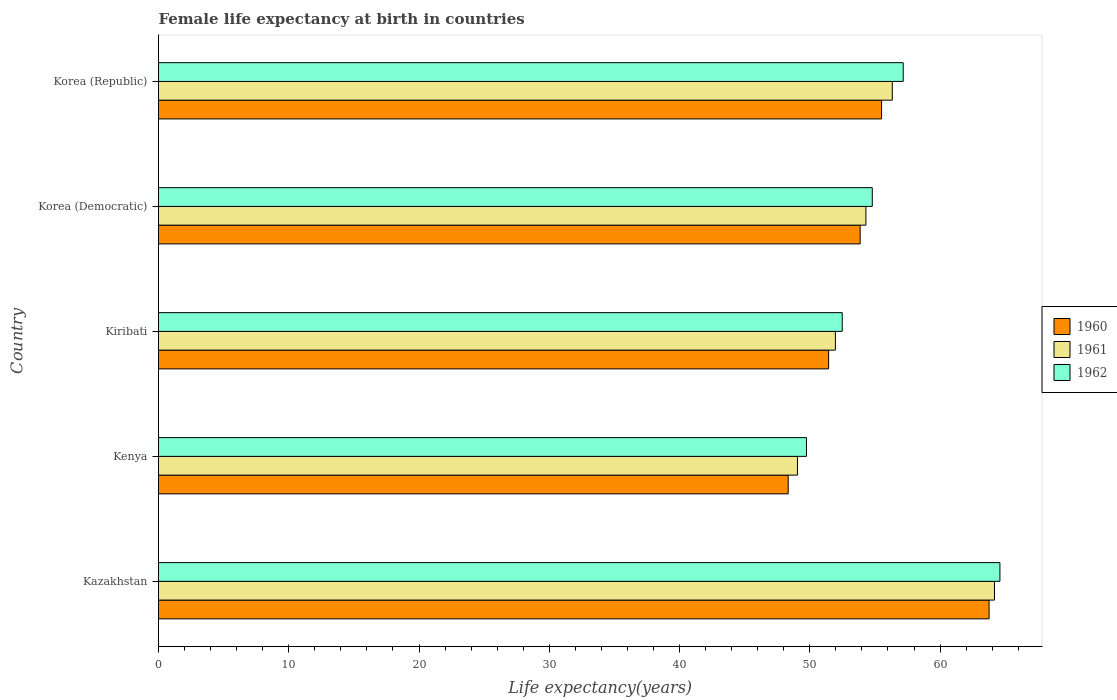How many different coloured bars are there?
Ensure brevity in your answer.  3. Are the number of bars per tick equal to the number of legend labels?
Offer a very short reply. Yes. Are the number of bars on each tick of the Y-axis equal?
Your answer should be compact. Yes. How many bars are there on the 5th tick from the top?
Make the answer very short. 3. What is the label of the 3rd group of bars from the top?
Your response must be concise. Kiribati. In how many cases, is the number of bars for a given country not equal to the number of legend labels?
Your answer should be very brief. 0. What is the female life expectancy at birth in 1961 in Kenya?
Make the answer very short. 49.05. Across all countries, what is the maximum female life expectancy at birth in 1960?
Provide a succinct answer. 63.76. Across all countries, what is the minimum female life expectancy at birth in 1960?
Give a very brief answer. 48.34. In which country was the female life expectancy at birth in 1960 maximum?
Your response must be concise. Kazakhstan. In which country was the female life expectancy at birth in 1960 minimum?
Offer a very short reply. Kenya. What is the total female life expectancy at birth in 1962 in the graph?
Provide a short and direct response. 278.79. What is the difference between the female life expectancy at birth in 1960 in Kiribati and that in Korea (Republic)?
Offer a very short reply. -4.06. What is the difference between the female life expectancy at birth in 1961 in Korea (Democratic) and the female life expectancy at birth in 1960 in Kazakhstan?
Offer a very short reply. -9.46. What is the average female life expectancy at birth in 1960 per country?
Your response must be concise. 54.58. What is the difference between the female life expectancy at birth in 1960 and female life expectancy at birth in 1961 in Korea (Democratic)?
Provide a short and direct response. -0.44. In how many countries, is the female life expectancy at birth in 1960 greater than 56 years?
Provide a short and direct response. 1. What is the ratio of the female life expectancy at birth in 1961 in Kazakhstan to that in Kiribati?
Provide a short and direct response. 1.24. Is the female life expectancy at birth in 1962 in Kazakhstan less than that in Korea (Democratic)?
Make the answer very short. No. What is the difference between the highest and the second highest female life expectancy at birth in 1961?
Provide a succinct answer. 7.84. What is the difference between the highest and the lowest female life expectancy at birth in 1960?
Ensure brevity in your answer.  15.42. Is the sum of the female life expectancy at birth in 1961 in Kazakhstan and Korea (Republic) greater than the maximum female life expectancy at birth in 1962 across all countries?
Your answer should be compact. Yes. What does the 1st bar from the top in Korea (Republic) represents?
Make the answer very short. 1962. Are all the bars in the graph horizontal?
Provide a short and direct response. Yes. Are the values on the major ticks of X-axis written in scientific E-notation?
Your response must be concise. No. Does the graph contain any zero values?
Provide a succinct answer. No. Where does the legend appear in the graph?
Give a very brief answer. Center right. How many legend labels are there?
Provide a short and direct response. 3. How are the legend labels stacked?
Your answer should be very brief. Vertical. What is the title of the graph?
Offer a very short reply. Female life expectancy at birth in countries. Does "2008" appear as one of the legend labels in the graph?
Your answer should be very brief. No. What is the label or title of the X-axis?
Provide a succinct answer. Life expectancy(years). What is the label or title of the Y-axis?
Your answer should be compact. Country. What is the Life expectancy(years) in 1960 in Kazakhstan?
Give a very brief answer. 63.76. What is the Life expectancy(years) in 1961 in Kazakhstan?
Provide a short and direct response. 64.17. What is the Life expectancy(years) of 1962 in Kazakhstan?
Your answer should be compact. 64.59. What is the Life expectancy(years) in 1960 in Kenya?
Provide a succinct answer. 48.34. What is the Life expectancy(years) in 1961 in Kenya?
Provide a succinct answer. 49.05. What is the Life expectancy(years) of 1962 in Kenya?
Your answer should be very brief. 49.74. What is the Life expectancy(years) of 1960 in Kiribati?
Provide a short and direct response. 51.44. What is the Life expectancy(years) in 1961 in Kiribati?
Offer a terse response. 51.96. What is the Life expectancy(years) in 1962 in Kiribati?
Offer a very short reply. 52.49. What is the Life expectancy(years) of 1960 in Korea (Democratic)?
Provide a short and direct response. 53.86. What is the Life expectancy(years) in 1961 in Korea (Democratic)?
Provide a short and direct response. 54.3. What is the Life expectancy(years) of 1962 in Korea (Democratic)?
Your answer should be very brief. 54.79. What is the Life expectancy(years) in 1960 in Korea (Republic)?
Make the answer very short. 55.51. What is the Life expectancy(years) in 1961 in Korea (Republic)?
Your answer should be compact. 56.33. What is the Life expectancy(years) in 1962 in Korea (Republic)?
Your answer should be very brief. 57.17. Across all countries, what is the maximum Life expectancy(years) of 1960?
Your response must be concise. 63.76. Across all countries, what is the maximum Life expectancy(years) of 1961?
Your answer should be very brief. 64.17. Across all countries, what is the maximum Life expectancy(years) of 1962?
Offer a terse response. 64.59. Across all countries, what is the minimum Life expectancy(years) of 1960?
Offer a terse response. 48.34. Across all countries, what is the minimum Life expectancy(years) in 1961?
Provide a short and direct response. 49.05. Across all countries, what is the minimum Life expectancy(years) of 1962?
Offer a terse response. 49.74. What is the total Life expectancy(years) in 1960 in the graph?
Offer a terse response. 272.92. What is the total Life expectancy(years) of 1961 in the graph?
Provide a short and direct response. 275.82. What is the total Life expectancy(years) in 1962 in the graph?
Provide a succinct answer. 278.79. What is the difference between the Life expectancy(years) of 1960 in Kazakhstan and that in Kenya?
Offer a very short reply. 15.42. What is the difference between the Life expectancy(years) of 1961 in Kazakhstan and that in Kenya?
Give a very brief answer. 15.12. What is the difference between the Life expectancy(years) of 1962 in Kazakhstan and that in Kenya?
Ensure brevity in your answer.  14.85. What is the difference between the Life expectancy(years) of 1960 in Kazakhstan and that in Kiribati?
Provide a succinct answer. 12.32. What is the difference between the Life expectancy(years) of 1961 in Kazakhstan and that in Kiribati?
Your answer should be very brief. 12.21. What is the difference between the Life expectancy(years) of 1962 in Kazakhstan and that in Kiribati?
Your response must be concise. 12.11. What is the difference between the Life expectancy(years) of 1960 in Kazakhstan and that in Korea (Democratic)?
Offer a very short reply. 9.9. What is the difference between the Life expectancy(years) in 1961 in Kazakhstan and that in Korea (Democratic)?
Provide a succinct answer. 9.87. What is the difference between the Life expectancy(years) of 1962 in Kazakhstan and that in Korea (Democratic)?
Offer a terse response. 9.8. What is the difference between the Life expectancy(years) of 1960 in Kazakhstan and that in Korea (Republic)?
Your response must be concise. 8.25. What is the difference between the Life expectancy(years) of 1961 in Kazakhstan and that in Korea (Republic)?
Your response must be concise. 7.84. What is the difference between the Life expectancy(years) in 1962 in Kazakhstan and that in Korea (Republic)?
Your response must be concise. 7.42. What is the difference between the Life expectancy(years) in 1960 in Kenya and that in Kiribati?
Offer a very short reply. -3.1. What is the difference between the Life expectancy(years) of 1961 in Kenya and that in Kiribati?
Offer a very short reply. -2.91. What is the difference between the Life expectancy(years) of 1962 in Kenya and that in Kiribati?
Provide a short and direct response. -2.75. What is the difference between the Life expectancy(years) in 1960 in Kenya and that in Korea (Democratic)?
Ensure brevity in your answer.  -5.52. What is the difference between the Life expectancy(years) of 1961 in Kenya and that in Korea (Democratic)?
Provide a succinct answer. -5.25. What is the difference between the Life expectancy(years) of 1962 in Kenya and that in Korea (Democratic)?
Ensure brevity in your answer.  -5.05. What is the difference between the Life expectancy(years) of 1960 in Kenya and that in Korea (Republic)?
Provide a short and direct response. -7.17. What is the difference between the Life expectancy(years) of 1961 in Kenya and that in Korea (Republic)?
Your answer should be compact. -7.28. What is the difference between the Life expectancy(years) of 1962 in Kenya and that in Korea (Republic)?
Give a very brief answer. -7.43. What is the difference between the Life expectancy(years) of 1960 in Kiribati and that in Korea (Democratic)?
Your response must be concise. -2.42. What is the difference between the Life expectancy(years) of 1961 in Kiribati and that in Korea (Democratic)?
Offer a terse response. -2.34. What is the difference between the Life expectancy(years) of 1962 in Kiribati and that in Korea (Democratic)?
Make the answer very short. -2.31. What is the difference between the Life expectancy(years) in 1960 in Kiribati and that in Korea (Republic)?
Your answer should be very brief. -4.07. What is the difference between the Life expectancy(years) in 1961 in Kiribati and that in Korea (Republic)?
Offer a terse response. -4.37. What is the difference between the Life expectancy(years) of 1962 in Kiribati and that in Korea (Republic)?
Offer a very short reply. -4.68. What is the difference between the Life expectancy(years) in 1960 in Korea (Democratic) and that in Korea (Republic)?
Keep it short and to the point. -1.65. What is the difference between the Life expectancy(years) in 1961 in Korea (Democratic) and that in Korea (Republic)?
Offer a very short reply. -2.02. What is the difference between the Life expectancy(years) in 1962 in Korea (Democratic) and that in Korea (Republic)?
Your answer should be very brief. -2.37. What is the difference between the Life expectancy(years) of 1960 in Kazakhstan and the Life expectancy(years) of 1961 in Kenya?
Give a very brief answer. 14.71. What is the difference between the Life expectancy(years) in 1960 in Kazakhstan and the Life expectancy(years) in 1962 in Kenya?
Provide a short and direct response. 14.02. What is the difference between the Life expectancy(years) in 1961 in Kazakhstan and the Life expectancy(years) in 1962 in Kenya?
Provide a short and direct response. 14.43. What is the difference between the Life expectancy(years) in 1960 in Kazakhstan and the Life expectancy(years) in 1961 in Kiribati?
Your response must be concise. 11.8. What is the difference between the Life expectancy(years) in 1960 in Kazakhstan and the Life expectancy(years) in 1962 in Kiribati?
Give a very brief answer. 11.27. What is the difference between the Life expectancy(years) in 1961 in Kazakhstan and the Life expectancy(years) in 1962 in Kiribati?
Provide a succinct answer. 11.69. What is the difference between the Life expectancy(years) in 1960 in Kazakhstan and the Life expectancy(years) in 1961 in Korea (Democratic)?
Your response must be concise. 9.46. What is the difference between the Life expectancy(years) in 1960 in Kazakhstan and the Life expectancy(years) in 1962 in Korea (Democratic)?
Provide a succinct answer. 8.97. What is the difference between the Life expectancy(years) in 1961 in Kazakhstan and the Life expectancy(years) in 1962 in Korea (Democratic)?
Your response must be concise. 9.38. What is the difference between the Life expectancy(years) in 1960 in Kazakhstan and the Life expectancy(years) in 1961 in Korea (Republic)?
Your answer should be compact. 7.43. What is the difference between the Life expectancy(years) of 1960 in Kazakhstan and the Life expectancy(years) of 1962 in Korea (Republic)?
Give a very brief answer. 6.59. What is the difference between the Life expectancy(years) of 1961 in Kazakhstan and the Life expectancy(years) of 1962 in Korea (Republic)?
Your response must be concise. 7.01. What is the difference between the Life expectancy(years) of 1960 in Kenya and the Life expectancy(years) of 1961 in Kiribati?
Give a very brief answer. -3.62. What is the difference between the Life expectancy(years) of 1960 in Kenya and the Life expectancy(years) of 1962 in Kiribati?
Offer a terse response. -4.15. What is the difference between the Life expectancy(years) of 1961 in Kenya and the Life expectancy(years) of 1962 in Kiribati?
Offer a very short reply. -3.44. What is the difference between the Life expectancy(years) in 1960 in Kenya and the Life expectancy(years) in 1961 in Korea (Democratic)?
Provide a succinct answer. -5.96. What is the difference between the Life expectancy(years) in 1960 in Kenya and the Life expectancy(years) in 1962 in Korea (Democratic)?
Provide a succinct answer. -6.45. What is the difference between the Life expectancy(years) in 1961 in Kenya and the Life expectancy(years) in 1962 in Korea (Democratic)?
Your response must be concise. -5.74. What is the difference between the Life expectancy(years) in 1960 in Kenya and the Life expectancy(years) in 1961 in Korea (Republic)?
Your response must be concise. -7.99. What is the difference between the Life expectancy(years) of 1960 in Kenya and the Life expectancy(years) of 1962 in Korea (Republic)?
Offer a very short reply. -8.83. What is the difference between the Life expectancy(years) in 1961 in Kenya and the Life expectancy(years) in 1962 in Korea (Republic)?
Offer a very short reply. -8.12. What is the difference between the Life expectancy(years) in 1960 in Kiribati and the Life expectancy(years) in 1961 in Korea (Democratic)?
Offer a terse response. -2.86. What is the difference between the Life expectancy(years) in 1960 in Kiribati and the Life expectancy(years) in 1962 in Korea (Democratic)?
Ensure brevity in your answer.  -3.35. What is the difference between the Life expectancy(years) of 1961 in Kiribati and the Life expectancy(years) of 1962 in Korea (Democratic)?
Provide a succinct answer. -2.83. What is the difference between the Life expectancy(years) in 1960 in Kiribati and the Life expectancy(years) in 1961 in Korea (Republic)?
Provide a short and direct response. -4.89. What is the difference between the Life expectancy(years) in 1960 in Kiribati and the Life expectancy(years) in 1962 in Korea (Republic)?
Offer a very short reply. -5.72. What is the difference between the Life expectancy(years) in 1961 in Kiribati and the Life expectancy(years) in 1962 in Korea (Republic)?
Provide a short and direct response. -5.21. What is the difference between the Life expectancy(years) of 1960 in Korea (Democratic) and the Life expectancy(years) of 1961 in Korea (Republic)?
Your response must be concise. -2.47. What is the difference between the Life expectancy(years) of 1960 in Korea (Democratic) and the Life expectancy(years) of 1962 in Korea (Republic)?
Your response must be concise. -3.31. What is the difference between the Life expectancy(years) in 1961 in Korea (Democratic) and the Life expectancy(years) in 1962 in Korea (Republic)?
Your answer should be very brief. -2.86. What is the average Life expectancy(years) of 1960 per country?
Your answer should be compact. 54.58. What is the average Life expectancy(years) of 1961 per country?
Your response must be concise. 55.16. What is the average Life expectancy(years) of 1962 per country?
Keep it short and to the point. 55.76. What is the difference between the Life expectancy(years) in 1960 and Life expectancy(years) in 1961 in Kazakhstan?
Provide a short and direct response. -0.41. What is the difference between the Life expectancy(years) in 1960 and Life expectancy(years) in 1962 in Kazakhstan?
Offer a very short reply. -0.83. What is the difference between the Life expectancy(years) in 1961 and Life expectancy(years) in 1962 in Kazakhstan?
Your response must be concise. -0.42. What is the difference between the Life expectancy(years) in 1960 and Life expectancy(years) in 1961 in Kenya?
Make the answer very short. -0.71. What is the difference between the Life expectancy(years) in 1960 and Life expectancy(years) in 1962 in Kenya?
Ensure brevity in your answer.  -1.4. What is the difference between the Life expectancy(years) in 1961 and Life expectancy(years) in 1962 in Kenya?
Offer a very short reply. -0.69. What is the difference between the Life expectancy(years) of 1960 and Life expectancy(years) of 1961 in Kiribati?
Provide a succinct answer. -0.52. What is the difference between the Life expectancy(years) of 1960 and Life expectancy(years) of 1962 in Kiribati?
Your response must be concise. -1.04. What is the difference between the Life expectancy(years) in 1961 and Life expectancy(years) in 1962 in Kiribati?
Make the answer very short. -0.53. What is the difference between the Life expectancy(years) of 1960 and Life expectancy(years) of 1961 in Korea (Democratic)?
Keep it short and to the point. -0.44. What is the difference between the Life expectancy(years) in 1960 and Life expectancy(years) in 1962 in Korea (Democratic)?
Your answer should be very brief. -0.93. What is the difference between the Life expectancy(years) in 1961 and Life expectancy(years) in 1962 in Korea (Democratic)?
Offer a very short reply. -0.49. What is the difference between the Life expectancy(years) of 1960 and Life expectancy(years) of 1961 in Korea (Republic)?
Give a very brief answer. -0.82. What is the difference between the Life expectancy(years) of 1960 and Life expectancy(years) of 1962 in Korea (Republic)?
Keep it short and to the point. -1.66. What is the difference between the Life expectancy(years) of 1961 and Life expectancy(years) of 1962 in Korea (Republic)?
Your answer should be very brief. -0.84. What is the ratio of the Life expectancy(years) of 1960 in Kazakhstan to that in Kenya?
Your answer should be very brief. 1.32. What is the ratio of the Life expectancy(years) of 1961 in Kazakhstan to that in Kenya?
Make the answer very short. 1.31. What is the ratio of the Life expectancy(years) in 1962 in Kazakhstan to that in Kenya?
Offer a very short reply. 1.3. What is the ratio of the Life expectancy(years) of 1960 in Kazakhstan to that in Kiribati?
Provide a succinct answer. 1.24. What is the ratio of the Life expectancy(years) of 1961 in Kazakhstan to that in Kiribati?
Keep it short and to the point. 1.24. What is the ratio of the Life expectancy(years) in 1962 in Kazakhstan to that in Kiribati?
Your answer should be compact. 1.23. What is the ratio of the Life expectancy(years) in 1960 in Kazakhstan to that in Korea (Democratic)?
Your response must be concise. 1.18. What is the ratio of the Life expectancy(years) in 1961 in Kazakhstan to that in Korea (Democratic)?
Ensure brevity in your answer.  1.18. What is the ratio of the Life expectancy(years) in 1962 in Kazakhstan to that in Korea (Democratic)?
Provide a short and direct response. 1.18. What is the ratio of the Life expectancy(years) in 1960 in Kazakhstan to that in Korea (Republic)?
Keep it short and to the point. 1.15. What is the ratio of the Life expectancy(years) of 1961 in Kazakhstan to that in Korea (Republic)?
Offer a very short reply. 1.14. What is the ratio of the Life expectancy(years) in 1962 in Kazakhstan to that in Korea (Republic)?
Make the answer very short. 1.13. What is the ratio of the Life expectancy(years) in 1960 in Kenya to that in Kiribati?
Provide a succinct answer. 0.94. What is the ratio of the Life expectancy(years) of 1961 in Kenya to that in Kiribati?
Your response must be concise. 0.94. What is the ratio of the Life expectancy(years) of 1962 in Kenya to that in Kiribati?
Offer a terse response. 0.95. What is the ratio of the Life expectancy(years) in 1960 in Kenya to that in Korea (Democratic)?
Your answer should be very brief. 0.9. What is the ratio of the Life expectancy(years) of 1961 in Kenya to that in Korea (Democratic)?
Keep it short and to the point. 0.9. What is the ratio of the Life expectancy(years) in 1962 in Kenya to that in Korea (Democratic)?
Make the answer very short. 0.91. What is the ratio of the Life expectancy(years) of 1960 in Kenya to that in Korea (Republic)?
Keep it short and to the point. 0.87. What is the ratio of the Life expectancy(years) in 1961 in Kenya to that in Korea (Republic)?
Your response must be concise. 0.87. What is the ratio of the Life expectancy(years) in 1962 in Kenya to that in Korea (Republic)?
Give a very brief answer. 0.87. What is the ratio of the Life expectancy(years) in 1960 in Kiribati to that in Korea (Democratic)?
Provide a short and direct response. 0.96. What is the ratio of the Life expectancy(years) in 1961 in Kiribati to that in Korea (Democratic)?
Provide a succinct answer. 0.96. What is the ratio of the Life expectancy(years) of 1962 in Kiribati to that in Korea (Democratic)?
Offer a terse response. 0.96. What is the ratio of the Life expectancy(years) of 1960 in Kiribati to that in Korea (Republic)?
Your answer should be very brief. 0.93. What is the ratio of the Life expectancy(years) in 1961 in Kiribati to that in Korea (Republic)?
Offer a very short reply. 0.92. What is the ratio of the Life expectancy(years) in 1962 in Kiribati to that in Korea (Republic)?
Give a very brief answer. 0.92. What is the ratio of the Life expectancy(years) in 1960 in Korea (Democratic) to that in Korea (Republic)?
Ensure brevity in your answer.  0.97. What is the ratio of the Life expectancy(years) in 1961 in Korea (Democratic) to that in Korea (Republic)?
Your response must be concise. 0.96. What is the ratio of the Life expectancy(years) in 1962 in Korea (Democratic) to that in Korea (Republic)?
Provide a short and direct response. 0.96. What is the difference between the highest and the second highest Life expectancy(years) in 1960?
Your answer should be compact. 8.25. What is the difference between the highest and the second highest Life expectancy(years) in 1961?
Offer a terse response. 7.84. What is the difference between the highest and the second highest Life expectancy(years) in 1962?
Make the answer very short. 7.42. What is the difference between the highest and the lowest Life expectancy(years) in 1960?
Keep it short and to the point. 15.42. What is the difference between the highest and the lowest Life expectancy(years) of 1961?
Offer a very short reply. 15.12. What is the difference between the highest and the lowest Life expectancy(years) in 1962?
Offer a terse response. 14.85. 